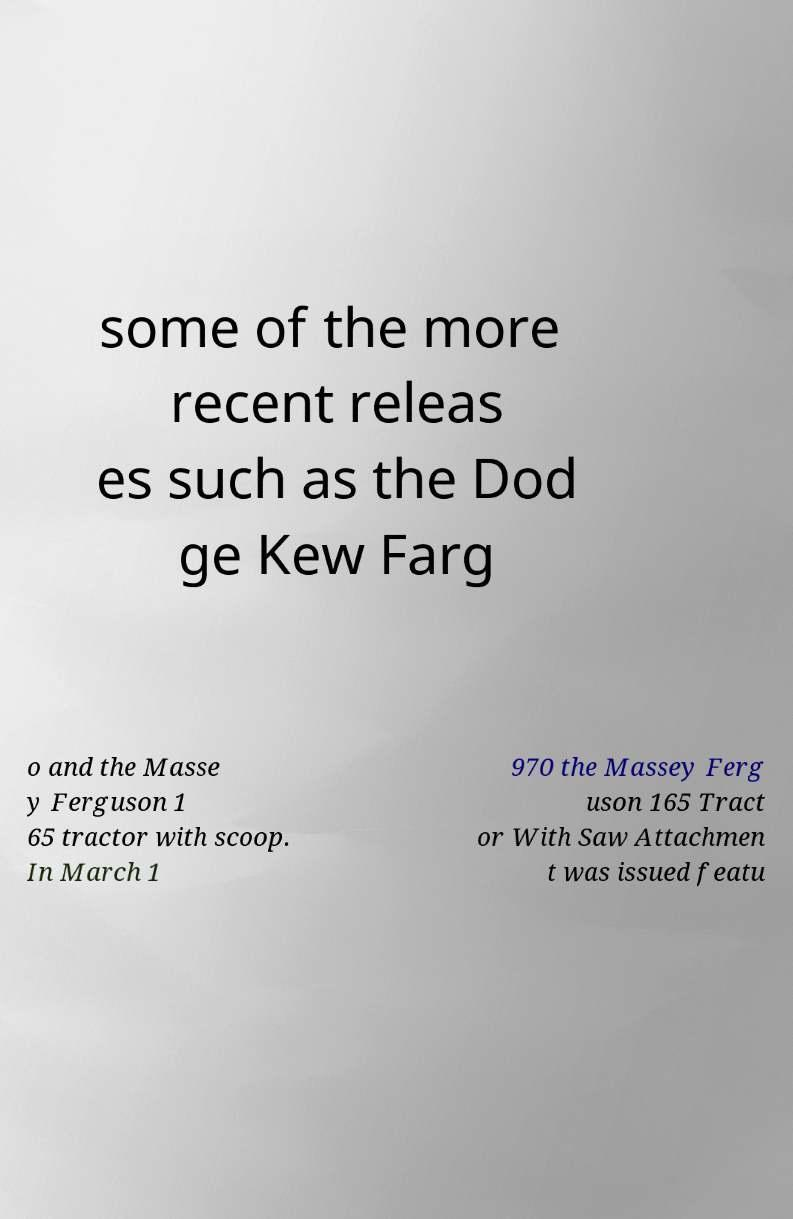Could you assist in decoding the text presented in this image and type it out clearly? some of the more recent releas es such as the Dod ge Kew Farg o and the Masse y Ferguson 1 65 tractor with scoop. In March 1 970 the Massey Ferg uson 165 Tract or With Saw Attachmen t was issued featu 